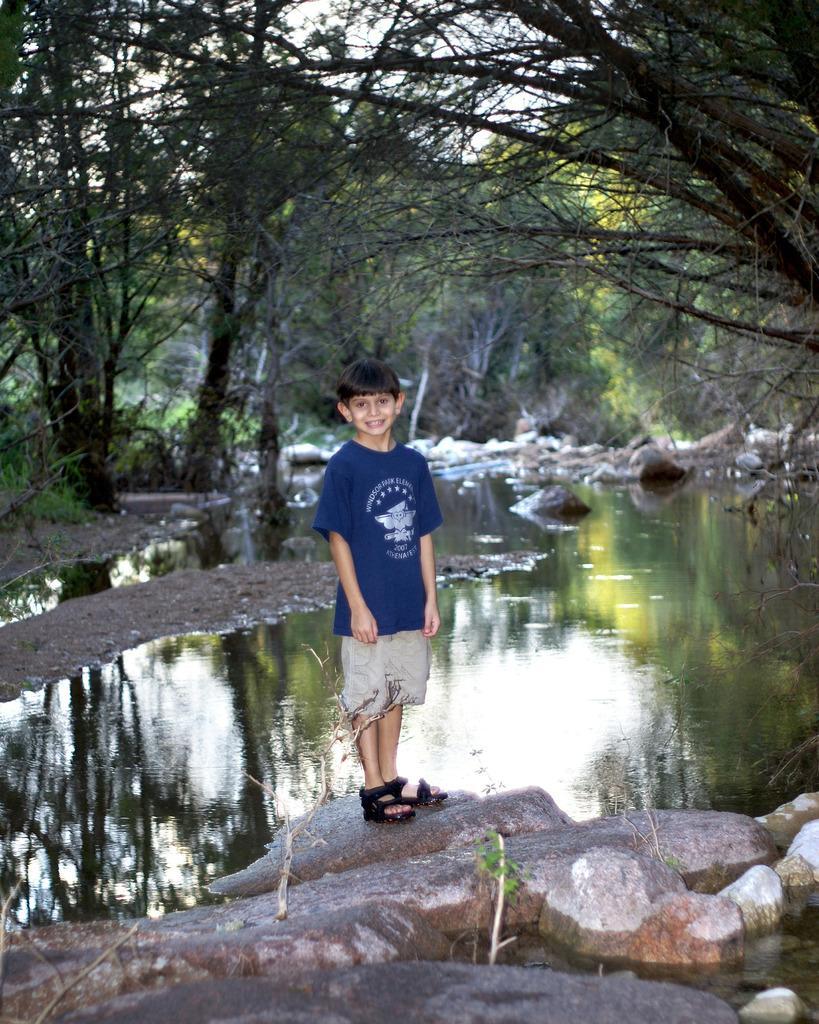Could you give a brief overview of what you see in this image? In this image I see a boy who is standing and I see that he is smiling. I can also see that he is wearing blue color t-shirt and shorts and I see the rocks. In the background I see the water and I see number of trees. 